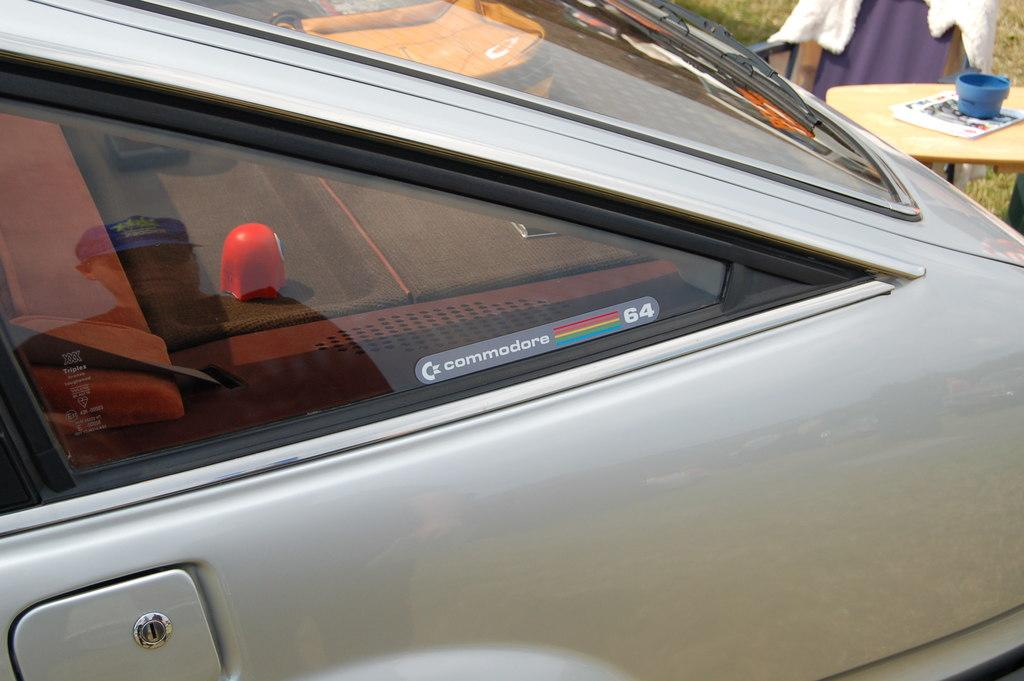What is written or displayed on the vehicle in the image? There is a board with text on a vehicle in the image. What is the object placed on the stand? There is a book placed on the stand. What else can be seen on the stand? There are no other objects visible on the stand, only the book. What is the state of the clothes in the image? The clothes are on a chair in the image. How many dolls are sitting on the chair with the clothes? There are no dolls present in the image; only clothes can be seen on the chair. What type of thrill can be experienced by the book on the stand? The book on the stand is not experiencing any thrill, as it is an inanimate object. 